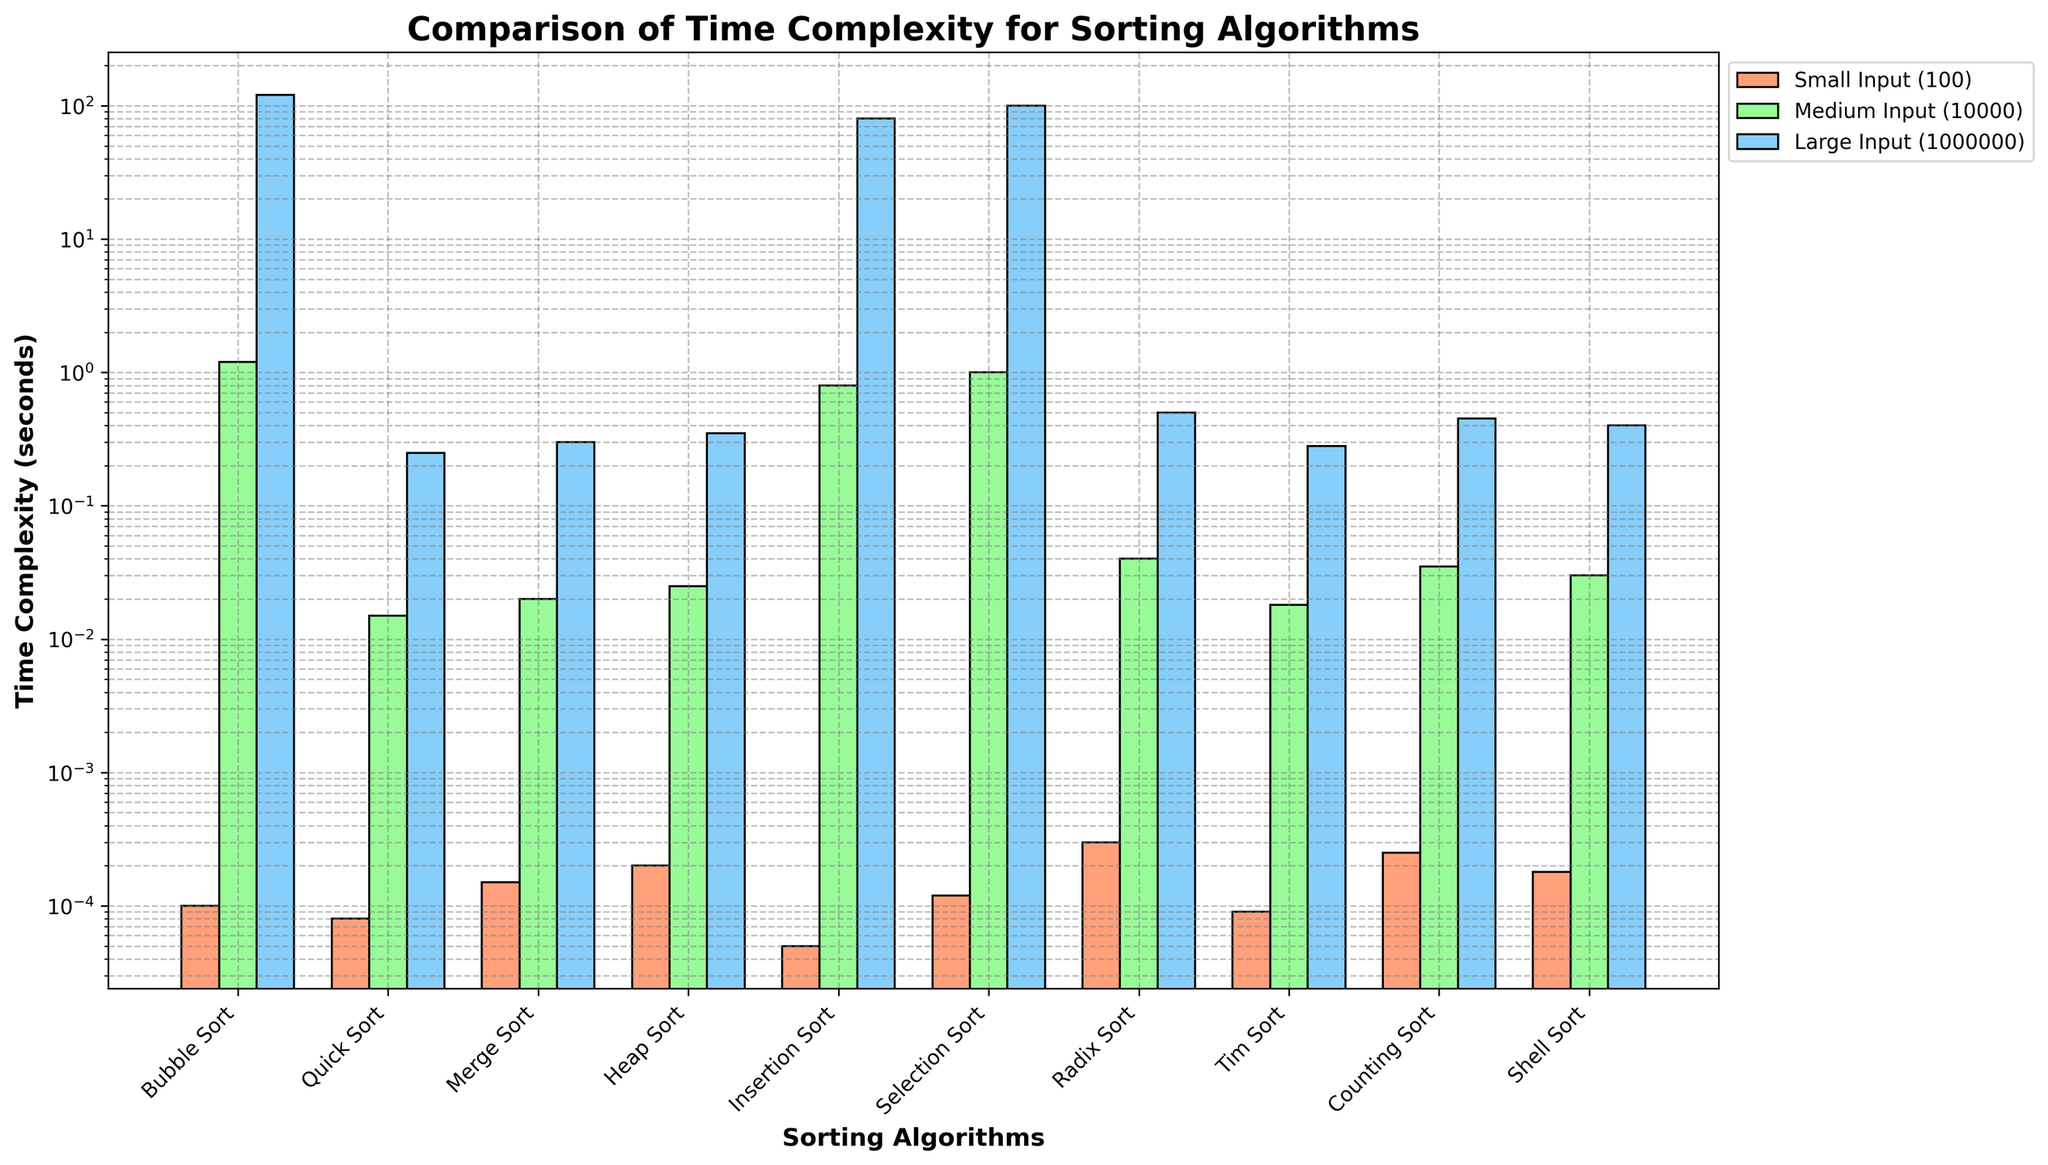Which algorithm has the smallest time complexity for 'Small Input (100)'? Looking at the smallest input size (100), we can see that the time complexity for each sorting algorithm is represented by the height of the red bars. The algorithm with the smallest red bar is Insertion Sort.
Answer: Insertion Sort Which algorithms perform better on 'Large Input (1000000)' compared to 'Medium Input (10000)'? By observing the height of the blue bars (Large Input) in comparison to the green bars (Medium Input), Quick Sort, Merge Sort, and Tim Sort show a much faster performance for larger input sizes, signifying better efficiency.
Answer: Quick Sort, Merge Sort, Tim Sort Which algorithm performs the worst on 'Large Input (1000000)'? For the largest input size (1000000), corresponding to the blue bars, Bubble Sort has the highest bar, indicating the worst performance in terms of time complexity.
Answer: Bubble Sort What is the average time complexity for Heap Sort across all input sizes? To find the average time complexity, sum the values for Heap Sort across all sizes and divide by 3: (0.0002 + 0.025 + 0.35) / 3 = 0.3752 / 3 ≈ 0.1251 seconds.
Answer: 0.1251 seconds Is Tim Sort faster or slower than Radix Sort for 'Medium Input (10000)'? By comparing the heights of the green bars for Tim Sort and Radix Sort, Tim Sort has a slightly lower bar (0.018) compared to Radix Sort (0.04), meaning Tim Sort is faster.
Answer: Faster Which algorithm has the most consistent performance across all input sizes? Consistency can be interpreted as having smaller differences in bar heights across input sizes. Quick Sort exhibits relatively small increases in time complexity from small to large inputs, suggesting consistent performance.
Answer: Quick Sort By what factor does the time complexity of Bubble Sort increase from 'Small Input (100)' to 'Medium Input (10000)'? The factors of increase can be calculated by dividing the time complexity for 'Medium Input' by the time complexity for 'Small Input': 1.2 / 0.0001 = 12000.
Answer: 12000 How does Quick Sort's performance compare on 'Medium Input (10000)' versus 'Large Input (1000000)'? Comparing the heights of the green and blue bars for Quick Sort, we can determine that the time complexity increases from 0.015 to 0.25 seconds, by a factor of approximately 16.67.
Answer: Factor of 16.67 Identify the algorithm with the steepest increase in time complexity from 'Small Input (100)' to 'Large Input (1000000)'. We need to look at the ratio by which the time complexity increases from small to large input. Bubble Sort increases from 0.0001 to 120.5 (1205000 times), which is the steepest increase among all algorithms.
Answer: Bubble Sort 